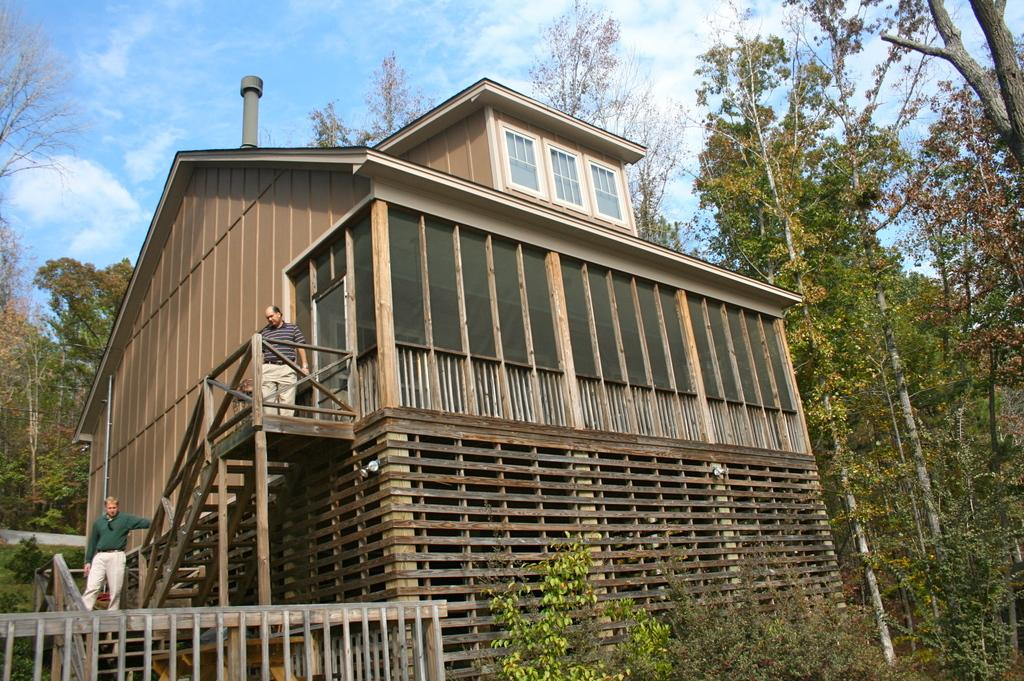What is the main subject in the center of the image? There is a building in the center of the image. What are the people in the image doing? The people are on the stairs of the building. What can be seen in the background of the image? There are trees in the background of the image. What is visible at the top of the image? There are clouds visible at the top of the image. What type of pickle is being used as a doorstop in the image? There is no pickle present in the image, and therefore no such object is being used as a doorstop. 